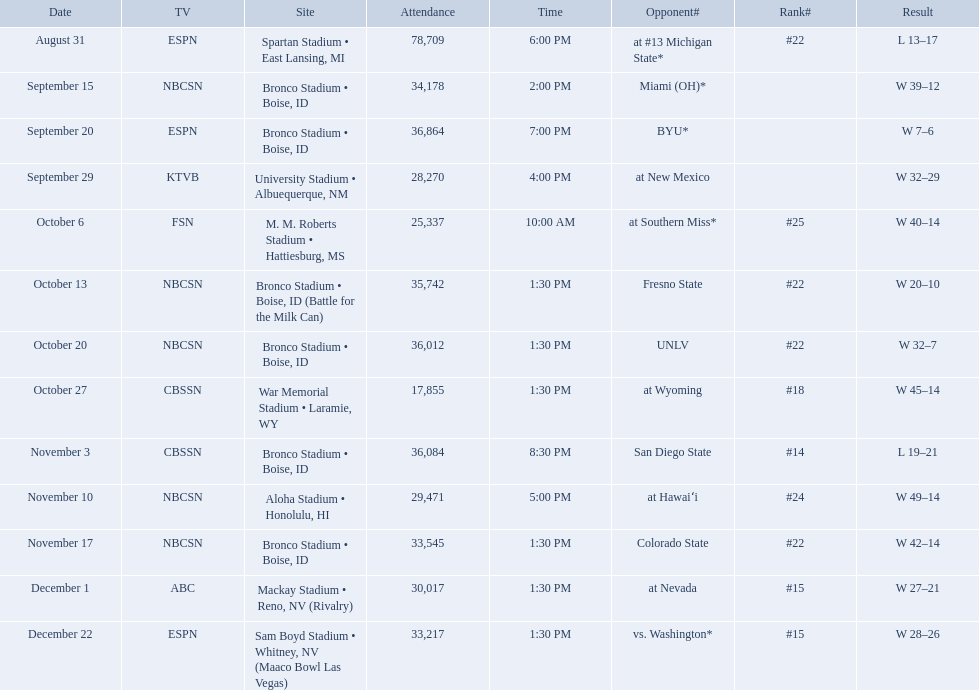What was the most consecutive wins for the team shown in the season? 7. 